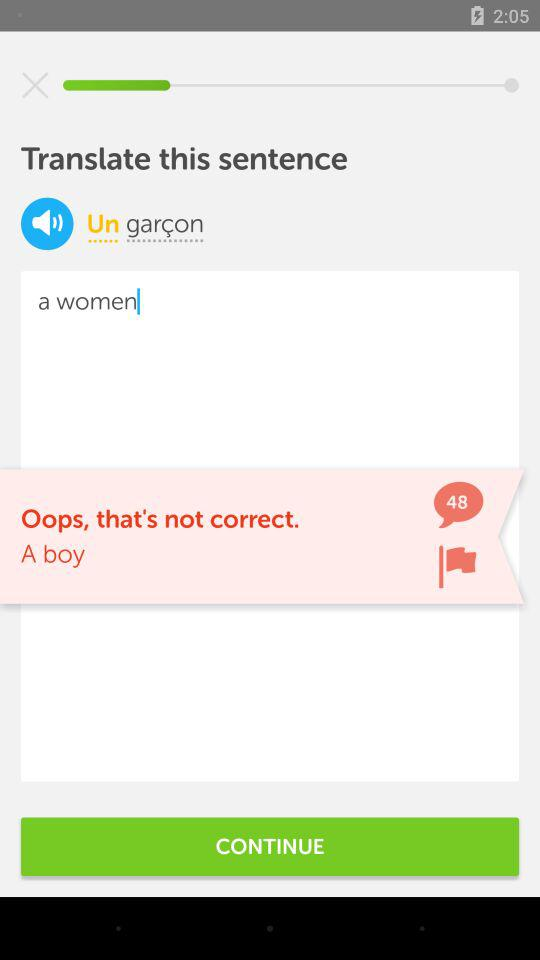How many reviews are there?
When the provided information is insufficient, respond with <no answer>. <no answer> 